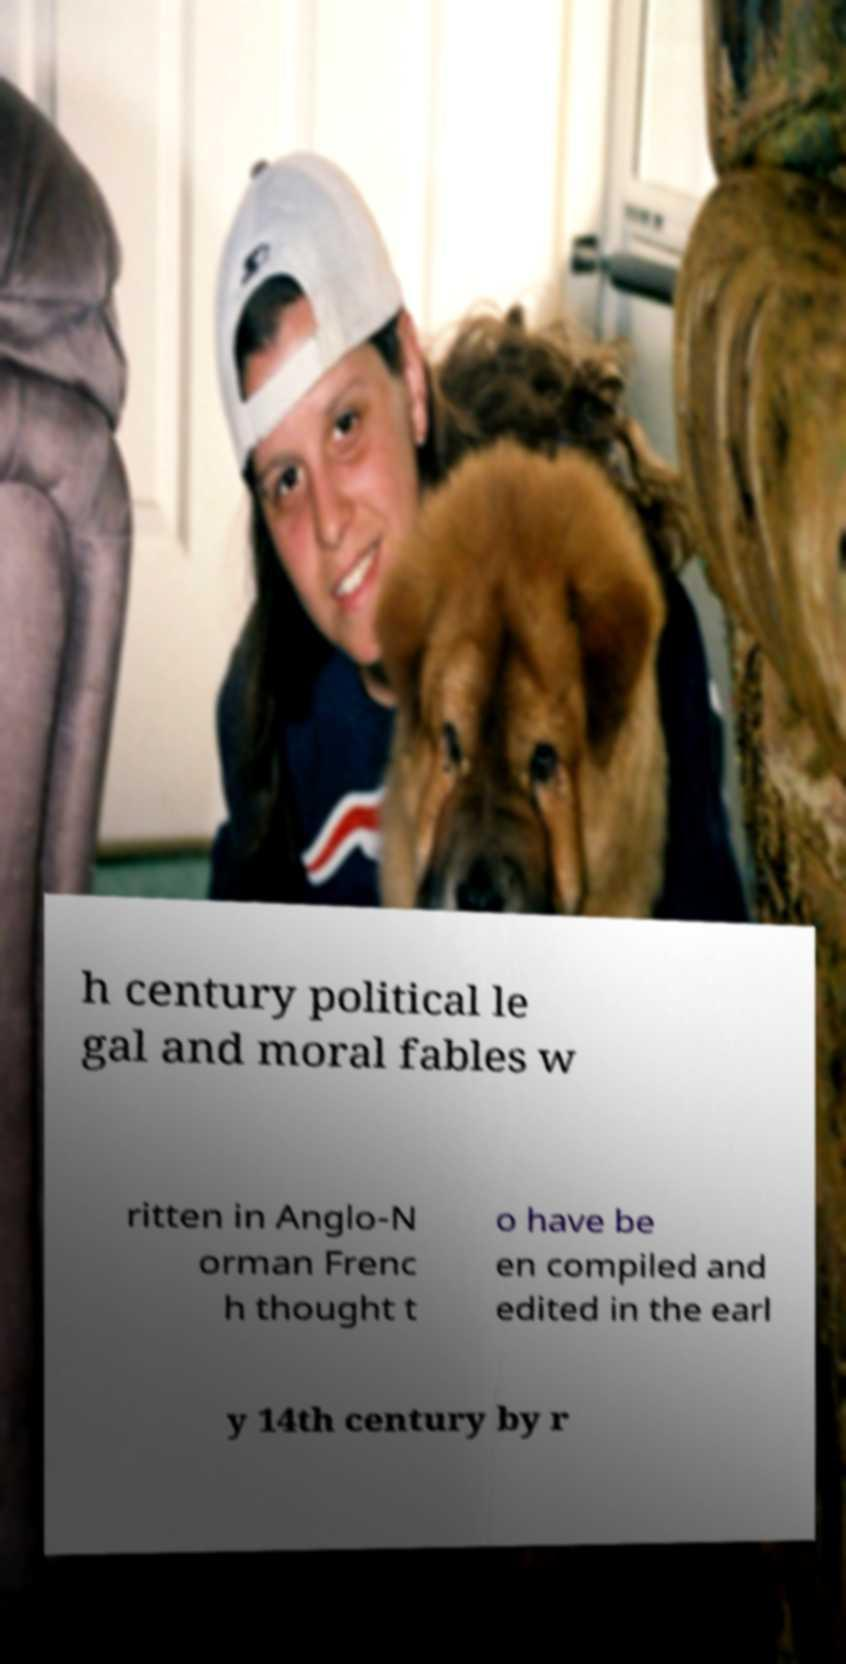For documentation purposes, I need the text within this image transcribed. Could you provide that? h century political le gal and moral fables w ritten in Anglo-N orman Frenc h thought t o have be en compiled and edited in the earl y 14th century by r 